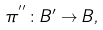Convert formula to latex. <formula><loc_0><loc_0><loc_500><loc_500>\pi ^ { ^ { \prime \prime } } \colon B ^ { \prime } \rightarrow B ,</formula> 